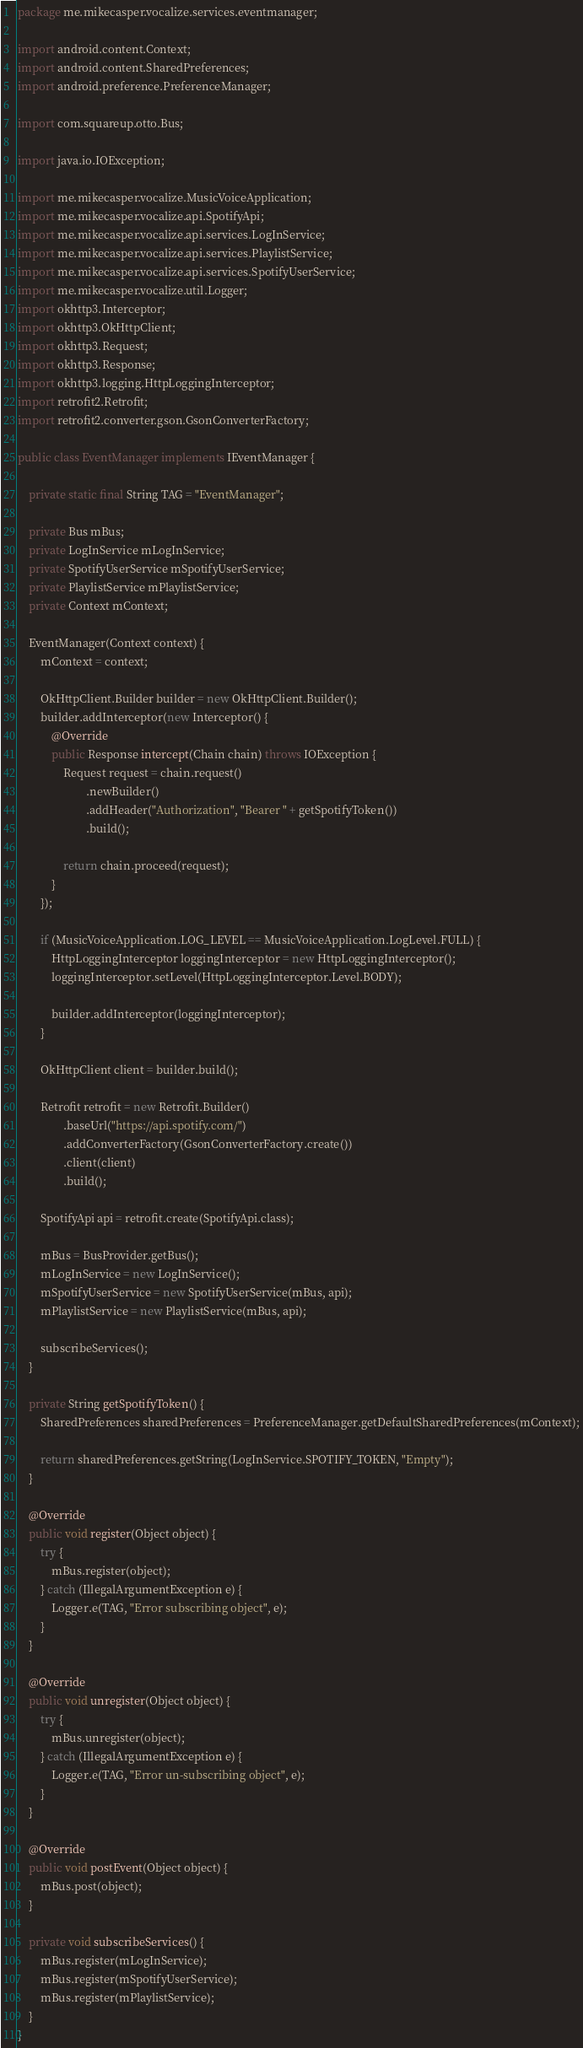Convert code to text. <code><loc_0><loc_0><loc_500><loc_500><_Java_>package me.mikecasper.vocalize.services.eventmanager;

import android.content.Context;
import android.content.SharedPreferences;
import android.preference.PreferenceManager;

import com.squareup.otto.Bus;

import java.io.IOException;

import me.mikecasper.vocalize.MusicVoiceApplication;
import me.mikecasper.vocalize.api.SpotifyApi;
import me.mikecasper.vocalize.api.services.LogInService;
import me.mikecasper.vocalize.api.services.PlaylistService;
import me.mikecasper.vocalize.api.services.SpotifyUserService;
import me.mikecasper.vocalize.util.Logger;
import okhttp3.Interceptor;
import okhttp3.OkHttpClient;
import okhttp3.Request;
import okhttp3.Response;
import okhttp3.logging.HttpLoggingInterceptor;
import retrofit2.Retrofit;
import retrofit2.converter.gson.GsonConverterFactory;

public class EventManager implements IEventManager {

    private static final String TAG = "EventManager";

    private Bus mBus;
    private LogInService mLogInService;
    private SpotifyUserService mSpotifyUserService;
    private PlaylistService mPlaylistService;
    private Context mContext;

    EventManager(Context context) {
        mContext = context;

        OkHttpClient.Builder builder = new OkHttpClient.Builder();
        builder.addInterceptor(new Interceptor() {
            @Override
            public Response intercept(Chain chain) throws IOException {
                Request request = chain.request()
                        .newBuilder()
                        .addHeader("Authorization", "Bearer " + getSpotifyToken())
                        .build();

                return chain.proceed(request);
            }
        });

        if (MusicVoiceApplication.LOG_LEVEL == MusicVoiceApplication.LogLevel.FULL) {
            HttpLoggingInterceptor loggingInterceptor = new HttpLoggingInterceptor();
            loggingInterceptor.setLevel(HttpLoggingInterceptor.Level.BODY);

            builder.addInterceptor(loggingInterceptor);
        }

        OkHttpClient client = builder.build();

        Retrofit retrofit = new Retrofit.Builder()
                .baseUrl("https://api.spotify.com/")
                .addConverterFactory(GsonConverterFactory.create())
                .client(client)
                .build();

        SpotifyApi api = retrofit.create(SpotifyApi.class);

        mBus = BusProvider.getBus();
        mLogInService = new LogInService();
        mSpotifyUserService = new SpotifyUserService(mBus, api);
        mPlaylistService = new PlaylistService(mBus, api);

        subscribeServices();
    }

    private String getSpotifyToken() {
        SharedPreferences sharedPreferences = PreferenceManager.getDefaultSharedPreferences(mContext);

        return sharedPreferences.getString(LogInService.SPOTIFY_TOKEN, "Empty");
    }

    @Override
    public void register(Object object) {
        try {
            mBus.register(object);
        } catch (IllegalArgumentException e) {
            Logger.e(TAG, "Error subscribing object", e);
        }
    }

    @Override
    public void unregister(Object object) {
        try {
            mBus.unregister(object);
        } catch (IllegalArgumentException e) {
            Logger.e(TAG, "Error un-subscribing object", e);
        }
    }

    @Override
    public void postEvent(Object object) {
        mBus.post(object);
    }

    private void subscribeServices() {
        mBus.register(mLogInService);
        mBus.register(mSpotifyUserService);
        mBus.register(mPlaylistService);
    }
}
</code> 